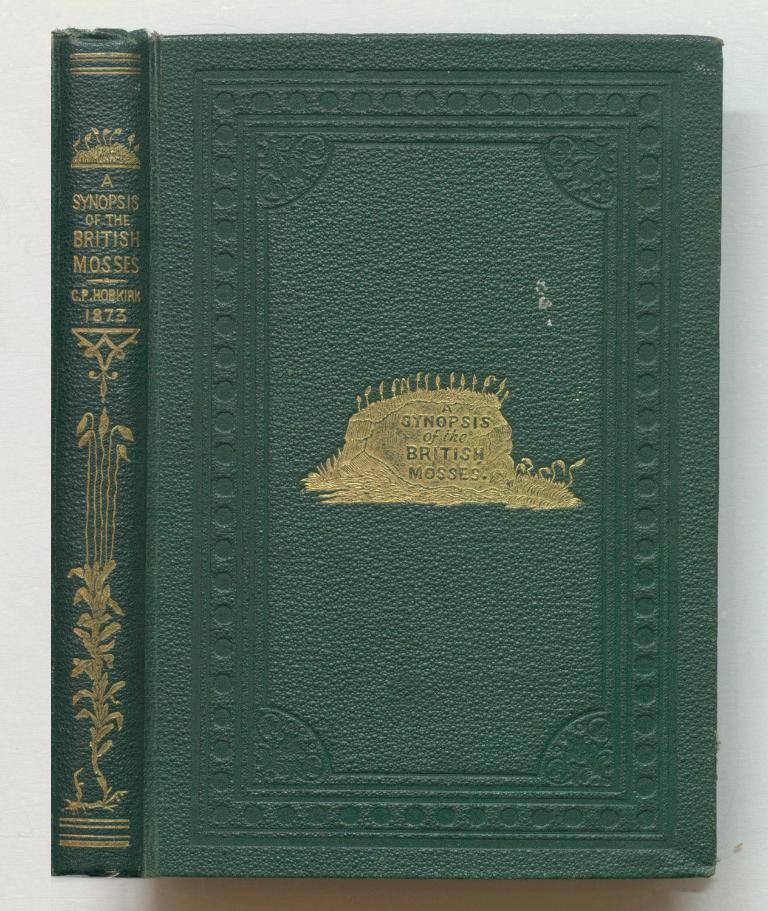<image>
Render a clear and concise summary of the photo. A green book says A Synopsis of the British Mosses. 